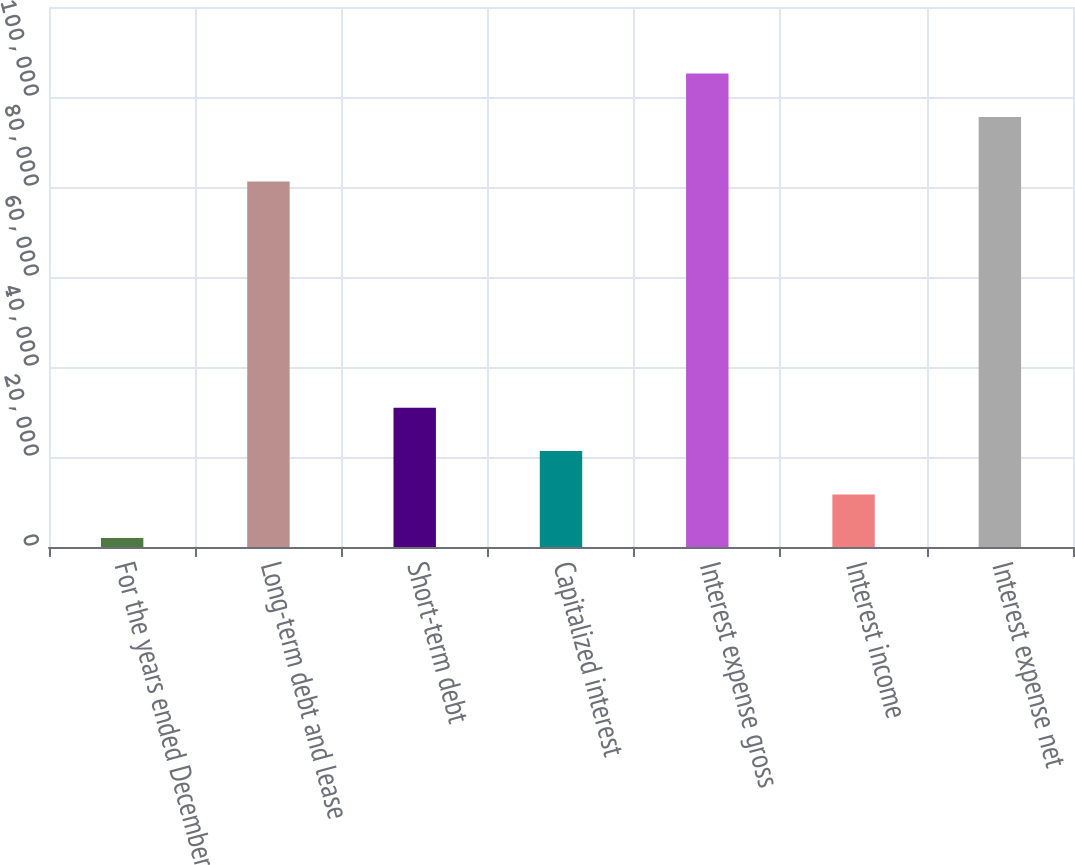Convert chart. <chart><loc_0><loc_0><loc_500><loc_500><bar_chart><fcel>For the years ended December<fcel>Long-term debt and lease<fcel>Short-term debt<fcel>Capitalized interest<fcel>Interest expense gross<fcel>Interest income<fcel>Interest expense net<nl><fcel>2012<fcel>81203<fcel>30961.1<fcel>21311.4<fcel>105219<fcel>11661.7<fcel>95569<nl></chart> 